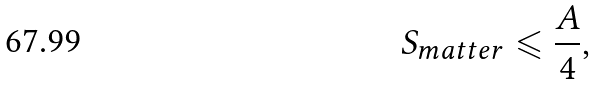<formula> <loc_0><loc_0><loc_500><loc_500>S _ { m a t t e r } \leqslant \frac { A } { 4 } ,</formula> 